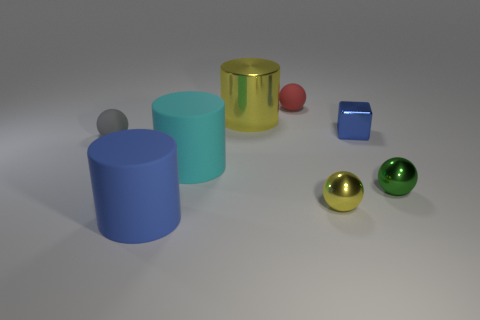Can you tell me how the lighting in the scene affects the appearance of the objects? The lighting in the scene is diffused, softening the shadows and highlights on the objects. It creates a calm and balanced appearance, making the objects' colors look more gentle and the reflective surfaces display subtle glints of light scattered across the scene. 